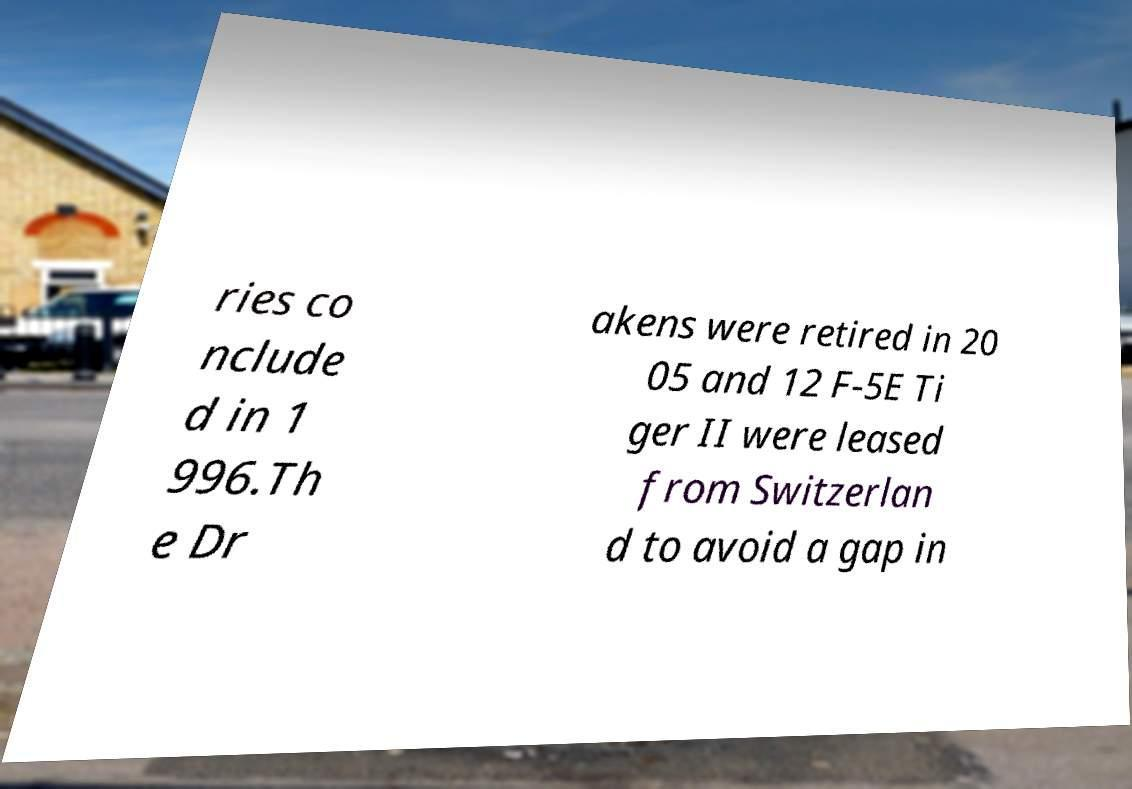Could you assist in decoding the text presented in this image and type it out clearly? ries co nclude d in 1 996.Th e Dr akens were retired in 20 05 and 12 F-5E Ti ger II were leased from Switzerlan d to avoid a gap in 